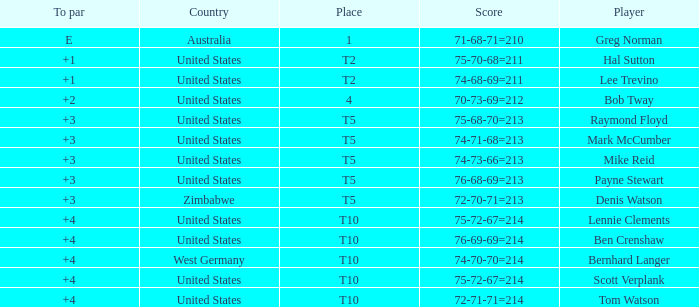Who is the competitor from the united states with a 75-70-68=211 score? Hal Sutton. 